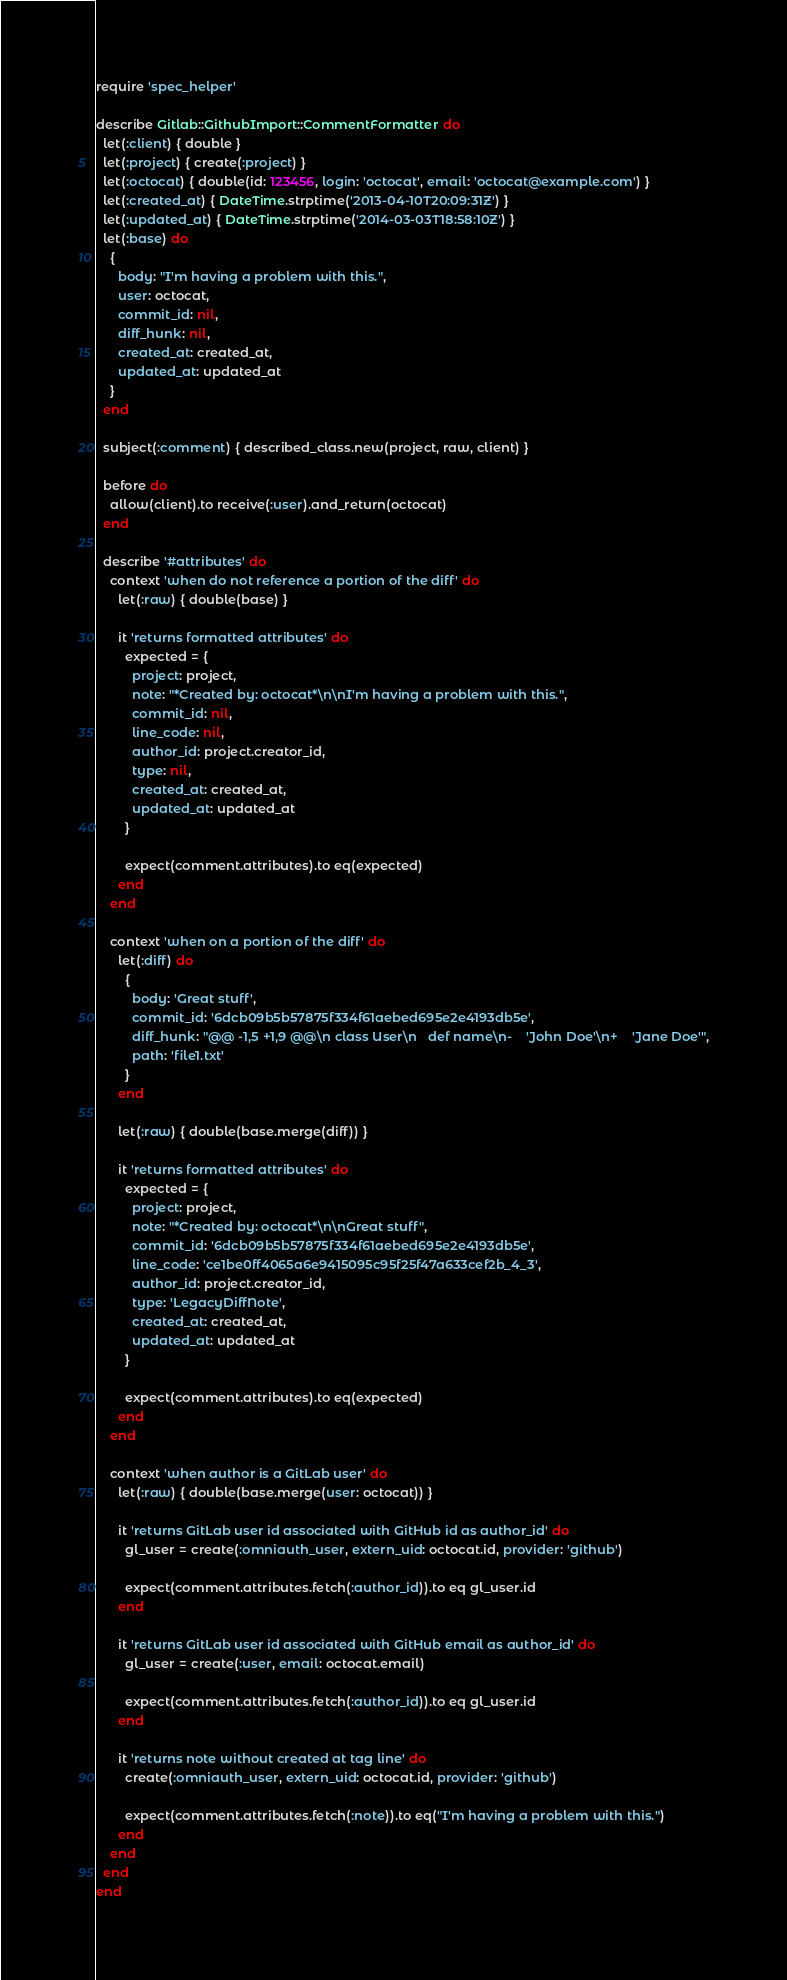Convert code to text. <code><loc_0><loc_0><loc_500><loc_500><_Ruby_>require 'spec_helper'

describe Gitlab::GithubImport::CommentFormatter do
  let(:client) { double }
  let(:project) { create(:project) }
  let(:octocat) { double(id: 123456, login: 'octocat', email: 'octocat@example.com') }
  let(:created_at) { DateTime.strptime('2013-04-10T20:09:31Z') }
  let(:updated_at) { DateTime.strptime('2014-03-03T18:58:10Z') }
  let(:base) do
    {
      body: "I'm having a problem with this.",
      user: octocat,
      commit_id: nil,
      diff_hunk: nil,
      created_at: created_at,
      updated_at: updated_at
    }
  end

  subject(:comment) { described_class.new(project, raw, client) }

  before do
    allow(client).to receive(:user).and_return(octocat)
  end

  describe '#attributes' do
    context 'when do not reference a portion of the diff' do
      let(:raw) { double(base) }

      it 'returns formatted attributes' do
        expected = {
          project: project,
          note: "*Created by: octocat*\n\nI'm having a problem with this.",
          commit_id: nil,
          line_code: nil,
          author_id: project.creator_id,
          type: nil,
          created_at: created_at,
          updated_at: updated_at
        }

        expect(comment.attributes).to eq(expected)
      end
    end

    context 'when on a portion of the diff' do
      let(:diff) do
        {
          body: 'Great stuff',
          commit_id: '6dcb09b5b57875f334f61aebed695e2e4193db5e',
          diff_hunk: "@@ -1,5 +1,9 @@\n class User\n   def name\n-    'John Doe'\n+    'Jane Doe'",
          path: 'file1.txt'
        }
      end

      let(:raw) { double(base.merge(diff)) }

      it 'returns formatted attributes' do
        expected = {
          project: project,
          note: "*Created by: octocat*\n\nGreat stuff",
          commit_id: '6dcb09b5b57875f334f61aebed695e2e4193db5e',
          line_code: 'ce1be0ff4065a6e9415095c95f25f47a633cef2b_4_3',
          author_id: project.creator_id,
          type: 'LegacyDiffNote',
          created_at: created_at,
          updated_at: updated_at
        }

        expect(comment.attributes).to eq(expected)
      end
    end

    context 'when author is a GitLab user' do
      let(:raw) { double(base.merge(user: octocat)) }

      it 'returns GitLab user id associated with GitHub id as author_id' do
        gl_user = create(:omniauth_user, extern_uid: octocat.id, provider: 'github')

        expect(comment.attributes.fetch(:author_id)).to eq gl_user.id
      end

      it 'returns GitLab user id associated with GitHub email as author_id' do
        gl_user = create(:user, email: octocat.email)

        expect(comment.attributes.fetch(:author_id)).to eq gl_user.id
      end

      it 'returns note without created at tag line' do
        create(:omniauth_user, extern_uid: octocat.id, provider: 'github')

        expect(comment.attributes.fetch(:note)).to eq("I'm having a problem with this.")
      end
    end
  end
end
</code> 